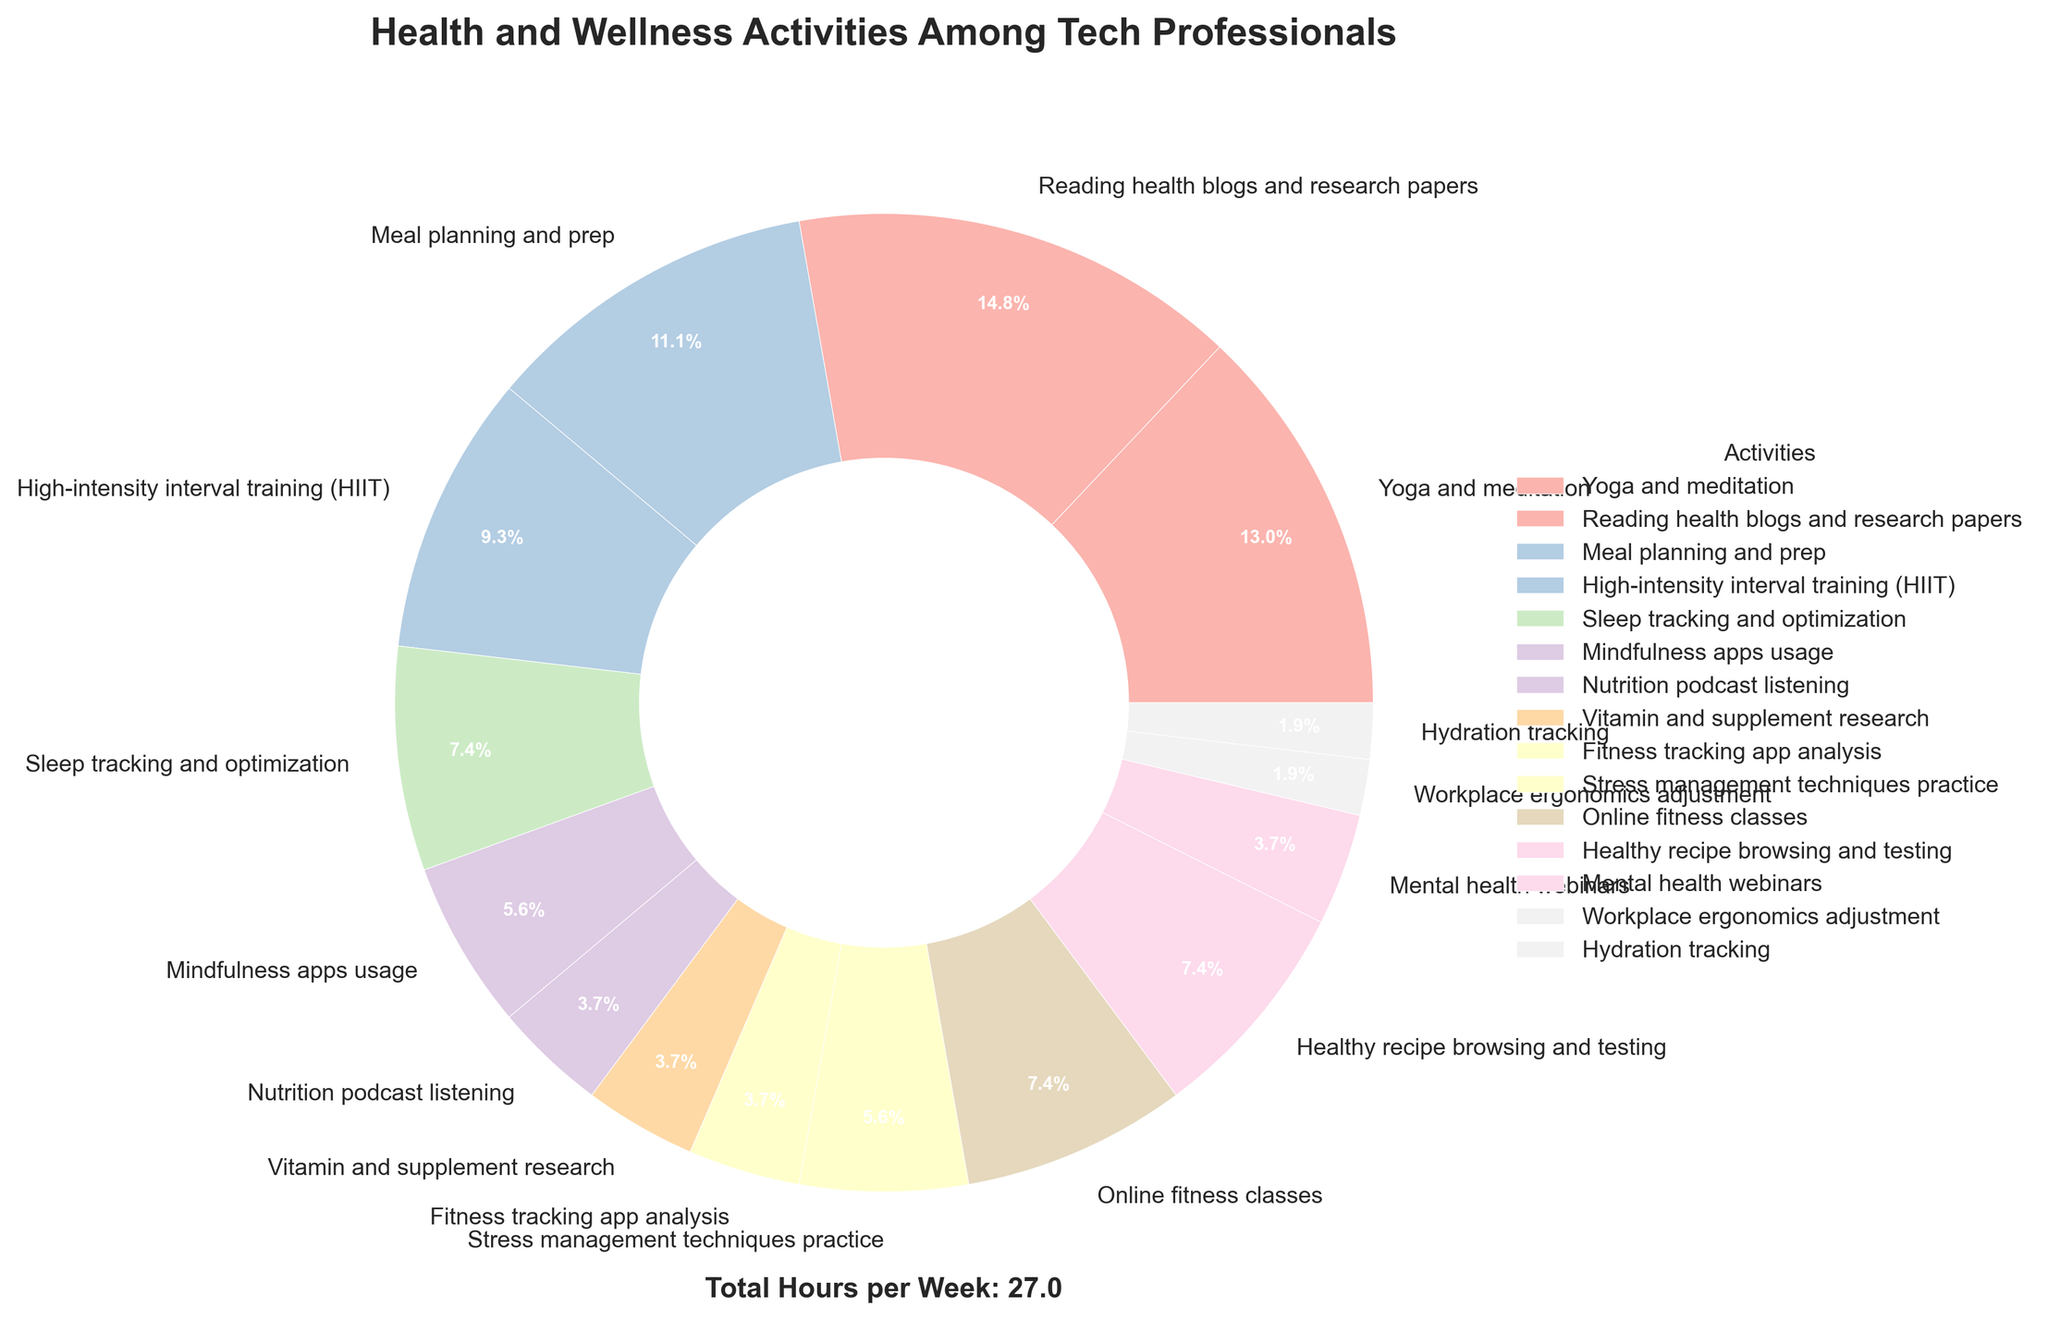Which activity takes up the most hours per week? By looking at the figure, we find the segment with the largest percentage which corresponds to "Reading health blogs and research papers." It takes up 4 hours per week.
Answer: Reading health blogs and research papers What percentage of time is spent on activities related to mental health (Yoga and meditation, Mindfulness apps usage, Stress management techniques practice, Mental health webinars)? Calculate the sum of hours for Yoga and meditation (3.5), Mindfulness apps usage (1.5), Stress management techniques practice (1.5), and Mental health webinars (1). The total is 3.5 + 1.5 + 1.5 + 1 = 7.5. The total hours per week spent on all activities is 25.5. The percentage is (7.5 / 25.5) * 100 ≈ 29.4%.
Answer: 29.4% Which activity is allotted the least time per week? Find the smallest segment in the pie chart, which corresponds to "Workplace ergonomics adjustment" and "Hydration tracking," each with 0.5 hours per week.
Answer: Workplace ergonomics adjustment and Hydration tracking How much more time is spent on "Meal planning and prep" compared to "High-intensity interval training (HIIT)"? Identify the hours spent on Meal planning and prep (3) and HIIT (2.5). The difference is 3 - 2.5 = 0.5 hours.
Answer: 0.5 hours What activities combined take up exactly 2 hours per week? Locate segments with 2 hours which include "Online fitness classes" and "Healthy recipe browsing and testing".
Answer: Online fitness classes and Healthy recipe browsing and testing What's the ratio of time spent on "Sleep tracking and optimization" to "Nutrition podcast listening"? Time spent on Sleep tracking and optimization is 2 hours. Time spent on Nutrition podcast listening is 1 hour. The ratio is 2:1.
Answer: 2:1 If the time spent on "Vitamin and supplement research" is doubled, what would be the new total hours per week for all activities? Current time on Vitamin and supplement research is 1 hour. Doubling it, the new total is 25.5 + 1 = 26.5 hours per week.
Answer: 26.5 hours Compare the time spent on "Fitness tracking app analysis" and "Mental health webinars." How much more or less time is spent on each? Both activities take up the same time, 1 hour per week. Therefore, the time spent is equal.
Answer: Equal time What fraction of the total time is spent on "High-intensity interval training (HIIT)"? Hours spent on HIIT is 2.5. The total hours per week is 25.5. The fraction is 2.5 / 25.5. Simplifying this fraction we get approximately 1/10.
Answer: 1/10 